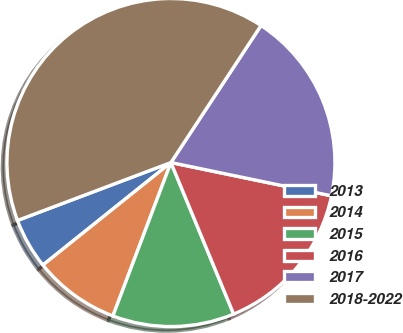Convert chart. <chart><loc_0><loc_0><loc_500><loc_500><pie_chart><fcel>2013<fcel>2014<fcel>2015<fcel>2016<fcel>2017<fcel>2018-2022<nl><fcel>5.0%<fcel>8.5%<fcel>12.0%<fcel>15.5%<fcel>19.0%<fcel>40.0%<nl></chart> 